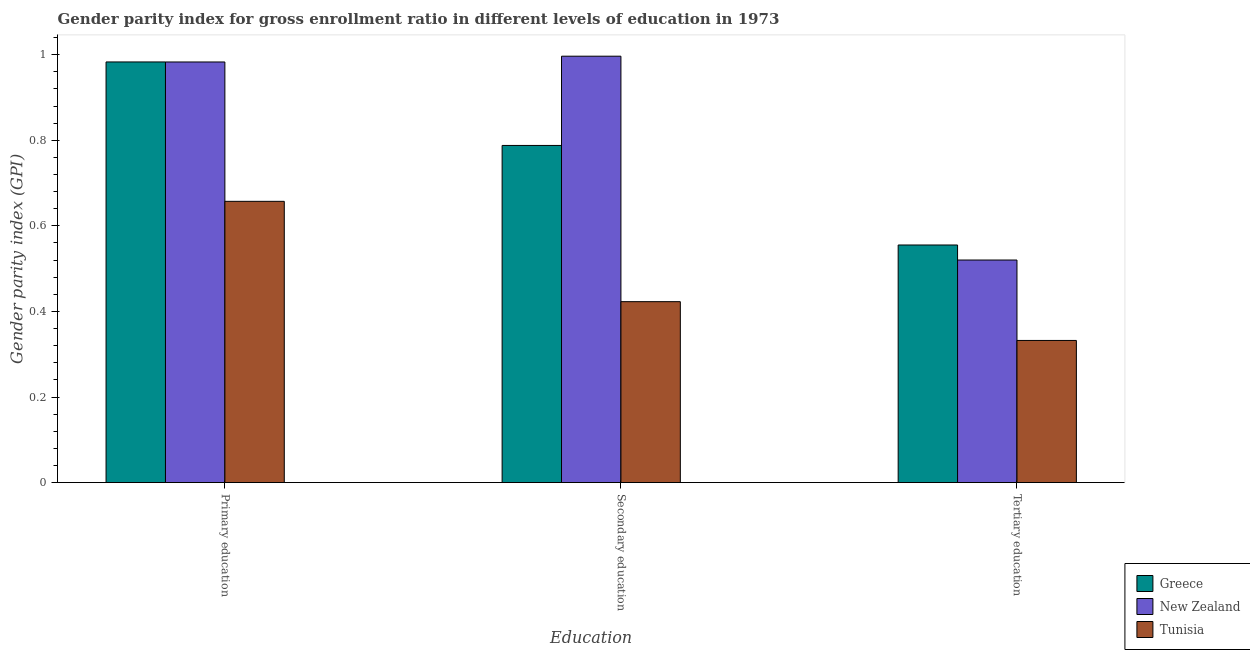How many different coloured bars are there?
Give a very brief answer. 3. How many groups of bars are there?
Make the answer very short. 3. Are the number of bars per tick equal to the number of legend labels?
Provide a short and direct response. Yes. Are the number of bars on each tick of the X-axis equal?
Make the answer very short. Yes. What is the label of the 1st group of bars from the left?
Provide a succinct answer. Primary education. What is the gender parity index in primary education in Tunisia?
Ensure brevity in your answer.  0.66. Across all countries, what is the maximum gender parity index in tertiary education?
Offer a terse response. 0.56. Across all countries, what is the minimum gender parity index in primary education?
Give a very brief answer. 0.66. In which country was the gender parity index in tertiary education minimum?
Offer a terse response. Tunisia. What is the total gender parity index in primary education in the graph?
Provide a succinct answer. 2.62. What is the difference between the gender parity index in secondary education in Greece and that in New Zealand?
Ensure brevity in your answer.  -0.21. What is the difference between the gender parity index in secondary education in Greece and the gender parity index in tertiary education in New Zealand?
Your answer should be compact. 0.27. What is the average gender parity index in primary education per country?
Provide a succinct answer. 0.87. What is the difference between the gender parity index in secondary education and gender parity index in primary education in Tunisia?
Ensure brevity in your answer.  -0.23. What is the ratio of the gender parity index in primary education in New Zealand to that in Tunisia?
Ensure brevity in your answer.  1.5. What is the difference between the highest and the second highest gender parity index in tertiary education?
Make the answer very short. 0.04. What is the difference between the highest and the lowest gender parity index in tertiary education?
Your response must be concise. 0.22. In how many countries, is the gender parity index in primary education greater than the average gender parity index in primary education taken over all countries?
Offer a very short reply. 2. Is the sum of the gender parity index in secondary education in New Zealand and Tunisia greater than the maximum gender parity index in primary education across all countries?
Give a very brief answer. Yes. What does the 3rd bar from the left in Secondary education represents?
Keep it short and to the point. Tunisia. What does the 3rd bar from the right in Primary education represents?
Your response must be concise. Greece. Is it the case that in every country, the sum of the gender parity index in primary education and gender parity index in secondary education is greater than the gender parity index in tertiary education?
Ensure brevity in your answer.  Yes. Are all the bars in the graph horizontal?
Give a very brief answer. No. What is the difference between two consecutive major ticks on the Y-axis?
Ensure brevity in your answer.  0.2. Are the values on the major ticks of Y-axis written in scientific E-notation?
Your answer should be very brief. No. What is the title of the graph?
Ensure brevity in your answer.  Gender parity index for gross enrollment ratio in different levels of education in 1973. Does "Peru" appear as one of the legend labels in the graph?
Give a very brief answer. No. What is the label or title of the X-axis?
Offer a very short reply. Education. What is the label or title of the Y-axis?
Your response must be concise. Gender parity index (GPI). What is the Gender parity index (GPI) of Greece in Primary education?
Your answer should be compact. 0.98. What is the Gender parity index (GPI) of New Zealand in Primary education?
Make the answer very short. 0.98. What is the Gender parity index (GPI) in Tunisia in Primary education?
Provide a short and direct response. 0.66. What is the Gender parity index (GPI) of Greece in Secondary education?
Give a very brief answer. 0.79. What is the Gender parity index (GPI) of New Zealand in Secondary education?
Offer a terse response. 1. What is the Gender parity index (GPI) in Tunisia in Secondary education?
Your answer should be very brief. 0.42. What is the Gender parity index (GPI) of Greece in Tertiary education?
Make the answer very short. 0.56. What is the Gender parity index (GPI) in New Zealand in Tertiary education?
Ensure brevity in your answer.  0.52. What is the Gender parity index (GPI) in Tunisia in Tertiary education?
Your answer should be very brief. 0.33. Across all Education, what is the maximum Gender parity index (GPI) in Greece?
Give a very brief answer. 0.98. Across all Education, what is the maximum Gender parity index (GPI) of New Zealand?
Make the answer very short. 1. Across all Education, what is the maximum Gender parity index (GPI) in Tunisia?
Keep it short and to the point. 0.66. Across all Education, what is the minimum Gender parity index (GPI) in Greece?
Give a very brief answer. 0.56. Across all Education, what is the minimum Gender parity index (GPI) in New Zealand?
Your response must be concise. 0.52. Across all Education, what is the minimum Gender parity index (GPI) in Tunisia?
Provide a short and direct response. 0.33. What is the total Gender parity index (GPI) of Greece in the graph?
Make the answer very short. 2.33. What is the total Gender parity index (GPI) in New Zealand in the graph?
Make the answer very short. 2.5. What is the total Gender parity index (GPI) of Tunisia in the graph?
Keep it short and to the point. 1.41. What is the difference between the Gender parity index (GPI) of Greece in Primary education and that in Secondary education?
Your response must be concise. 0.2. What is the difference between the Gender parity index (GPI) of New Zealand in Primary education and that in Secondary education?
Offer a terse response. -0.01. What is the difference between the Gender parity index (GPI) in Tunisia in Primary education and that in Secondary education?
Keep it short and to the point. 0.23. What is the difference between the Gender parity index (GPI) of Greece in Primary education and that in Tertiary education?
Keep it short and to the point. 0.43. What is the difference between the Gender parity index (GPI) in New Zealand in Primary education and that in Tertiary education?
Offer a very short reply. 0.46. What is the difference between the Gender parity index (GPI) of Tunisia in Primary education and that in Tertiary education?
Provide a succinct answer. 0.33. What is the difference between the Gender parity index (GPI) of Greece in Secondary education and that in Tertiary education?
Your response must be concise. 0.23. What is the difference between the Gender parity index (GPI) in New Zealand in Secondary education and that in Tertiary education?
Provide a succinct answer. 0.48. What is the difference between the Gender parity index (GPI) in Tunisia in Secondary education and that in Tertiary education?
Make the answer very short. 0.09. What is the difference between the Gender parity index (GPI) in Greece in Primary education and the Gender parity index (GPI) in New Zealand in Secondary education?
Make the answer very short. -0.01. What is the difference between the Gender parity index (GPI) of Greece in Primary education and the Gender parity index (GPI) of Tunisia in Secondary education?
Your response must be concise. 0.56. What is the difference between the Gender parity index (GPI) in New Zealand in Primary education and the Gender parity index (GPI) in Tunisia in Secondary education?
Provide a succinct answer. 0.56. What is the difference between the Gender parity index (GPI) in Greece in Primary education and the Gender parity index (GPI) in New Zealand in Tertiary education?
Keep it short and to the point. 0.46. What is the difference between the Gender parity index (GPI) in Greece in Primary education and the Gender parity index (GPI) in Tunisia in Tertiary education?
Provide a succinct answer. 0.65. What is the difference between the Gender parity index (GPI) of New Zealand in Primary education and the Gender parity index (GPI) of Tunisia in Tertiary education?
Your response must be concise. 0.65. What is the difference between the Gender parity index (GPI) in Greece in Secondary education and the Gender parity index (GPI) in New Zealand in Tertiary education?
Your response must be concise. 0.27. What is the difference between the Gender parity index (GPI) in Greece in Secondary education and the Gender parity index (GPI) in Tunisia in Tertiary education?
Make the answer very short. 0.46. What is the difference between the Gender parity index (GPI) in New Zealand in Secondary education and the Gender parity index (GPI) in Tunisia in Tertiary education?
Offer a terse response. 0.66. What is the average Gender parity index (GPI) of Greece per Education?
Keep it short and to the point. 0.78. What is the average Gender parity index (GPI) of Tunisia per Education?
Offer a very short reply. 0.47. What is the difference between the Gender parity index (GPI) of Greece and Gender parity index (GPI) of Tunisia in Primary education?
Your response must be concise. 0.33. What is the difference between the Gender parity index (GPI) of New Zealand and Gender parity index (GPI) of Tunisia in Primary education?
Offer a terse response. 0.33. What is the difference between the Gender parity index (GPI) of Greece and Gender parity index (GPI) of New Zealand in Secondary education?
Your answer should be very brief. -0.21. What is the difference between the Gender parity index (GPI) of Greece and Gender parity index (GPI) of Tunisia in Secondary education?
Give a very brief answer. 0.37. What is the difference between the Gender parity index (GPI) in New Zealand and Gender parity index (GPI) in Tunisia in Secondary education?
Offer a very short reply. 0.57. What is the difference between the Gender parity index (GPI) of Greece and Gender parity index (GPI) of New Zealand in Tertiary education?
Your answer should be compact. 0.04. What is the difference between the Gender parity index (GPI) in Greece and Gender parity index (GPI) in Tunisia in Tertiary education?
Offer a very short reply. 0.22. What is the difference between the Gender parity index (GPI) of New Zealand and Gender parity index (GPI) of Tunisia in Tertiary education?
Provide a short and direct response. 0.19. What is the ratio of the Gender parity index (GPI) of Greece in Primary education to that in Secondary education?
Provide a succinct answer. 1.25. What is the ratio of the Gender parity index (GPI) in New Zealand in Primary education to that in Secondary education?
Offer a terse response. 0.99. What is the ratio of the Gender parity index (GPI) of Tunisia in Primary education to that in Secondary education?
Your answer should be compact. 1.55. What is the ratio of the Gender parity index (GPI) of Greece in Primary education to that in Tertiary education?
Make the answer very short. 1.77. What is the ratio of the Gender parity index (GPI) of New Zealand in Primary education to that in Tertiary education?
Ensure brevity in your answer.  1.89. What is the ratio of the Gender parity index (GPI) of Tunisia in Primary education to that in Tertiary education?
Your answer should be very brief. 1.98. What is the ratio of the Gender parity index (GPI) of Greece in Secondary education to that in Tertiary education?
Your response must be concise. 1.42. What is the ratio of the Gender parity index (GPI) in New Zealand in Secondary education to that in Tertiary education?
Keep it short and to the point. 1.92. What is the ratio of the Gender parity index (GPI) of Tunisia in Secondary education to that in Tertiary education?
Your response must be concise. 1.27. What is the difference between the highest and the second highest Gender parity index (GPI) in Greece?
Make the answer very short. 0.2. What is the difference between the highest and the second highest Gender parity index (GPI) of New Zealand?
Ensure brevity in your answer.  0.01. What is the difference between the highest and the second highest Gender parity index (GPI) of Tunisia?
Offer a terse response. 0.23. What is the difference between the highest and the lowest Gender parity index (GPI) in Greece?
Your response must be concise. 0.43. What is the difference between the highest and the lowest Gender parity index (GPI) in New Zealand?
Ensure brevity in your answer.  0.48. What is the difference between the highest and the lowest Gender parity index (GPI) of Tunisia?
Offer a very short reply. 0.33. 